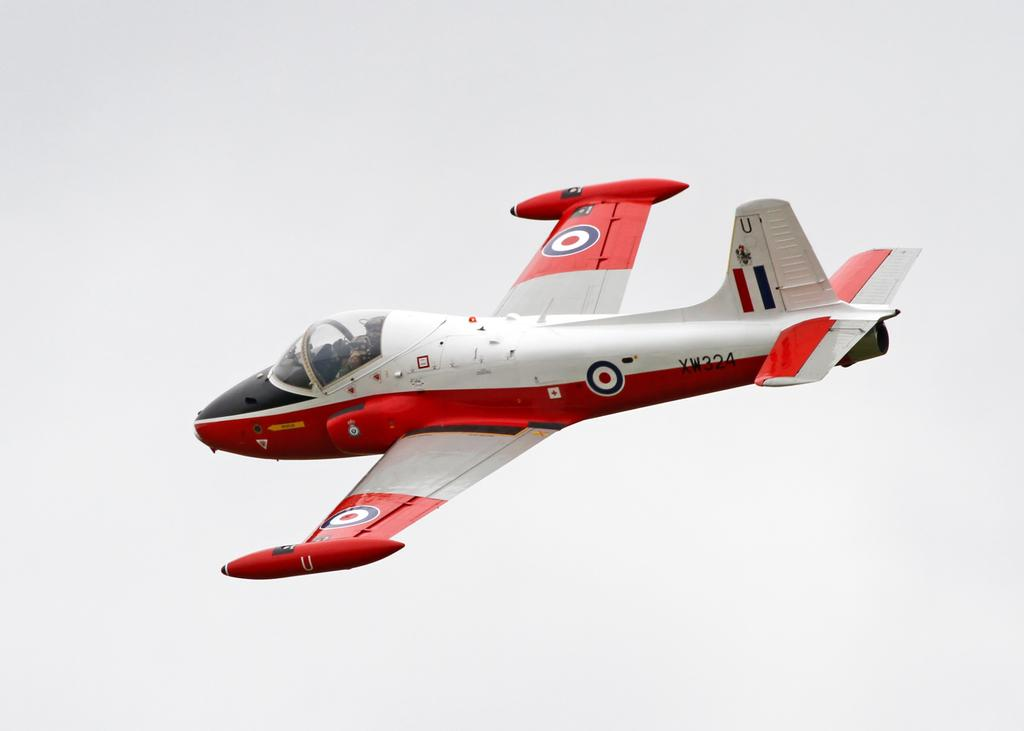<image>
Present a compact description of the photo's key features. A red and white plane showing the letters XW and numbers 324 